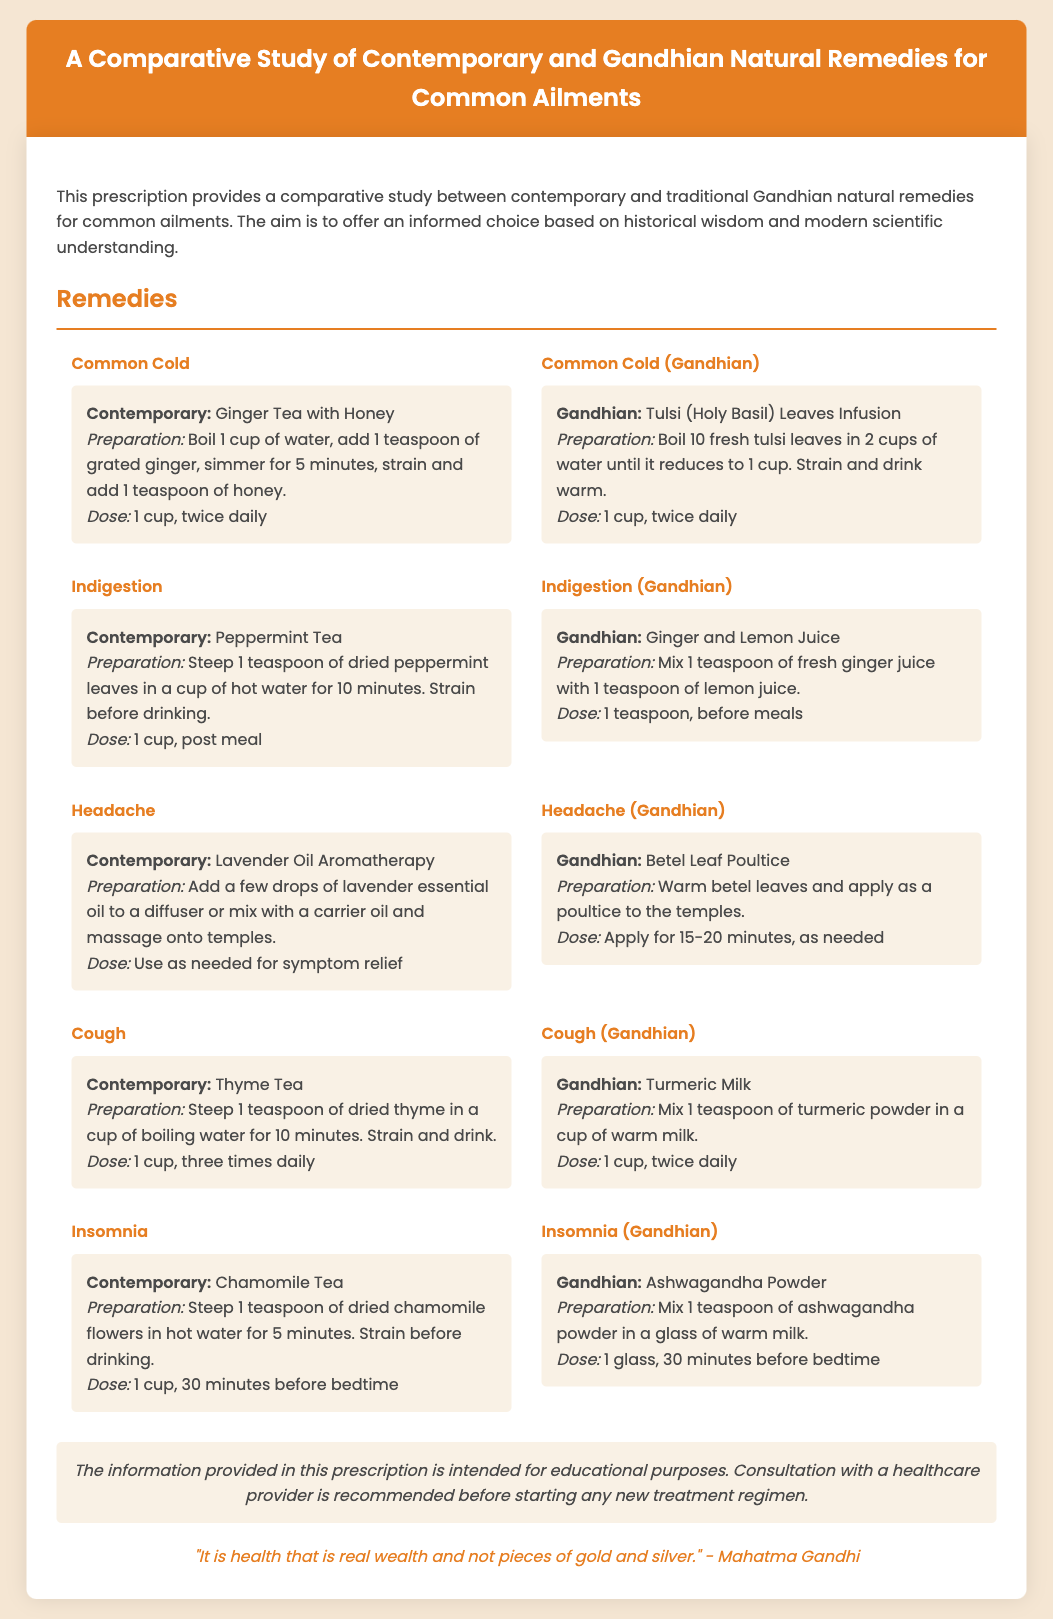What is the title of the document? The title is provided in the header of the document.
Answer: A Comparative Study of Contemporary and Gandhian Natural Remedies for Common Ailments What is the primary purpose of this prescription? The primary purpose is stated in the introductory paragraph of the document.
Answer: To offer an informed choice based on historical wisdom and modern scientific understanding What is the dose for Ginger Tea with Honey? The dose for this remedy is noted in the remedy content.
Answer: 1 cup, twice daily What is the preparation method for Tulsi Leaves Infusion? The preparation method is detailed in the Gandhian remedy content for common cold.
Answer: Boil 10 fresh tulsi leaves in 2 cups of water until it reduces to 1 cup. Strain and drink warm What remedy is suggested for insomnia in the document? The document provides remedies for insomnia under different categories.
Answer: Chamomile Tea and Ashwagandha Powder How many cups of Thyme Tea should one drink daily? The dose for Thyme Tea is located in the remedy content.
Answer: 3 cups, daily What is a common ailment treated with Turmeric Milk? The remedy is specified under the cough section of the document.
Answer: Cough What quote by Mahatma Gandhi is included at the end of the document? The quote is mentioned in the quote section at the bottom of the document.
Answer: "It is health that is real wealth and not pieces of gold and silver." 